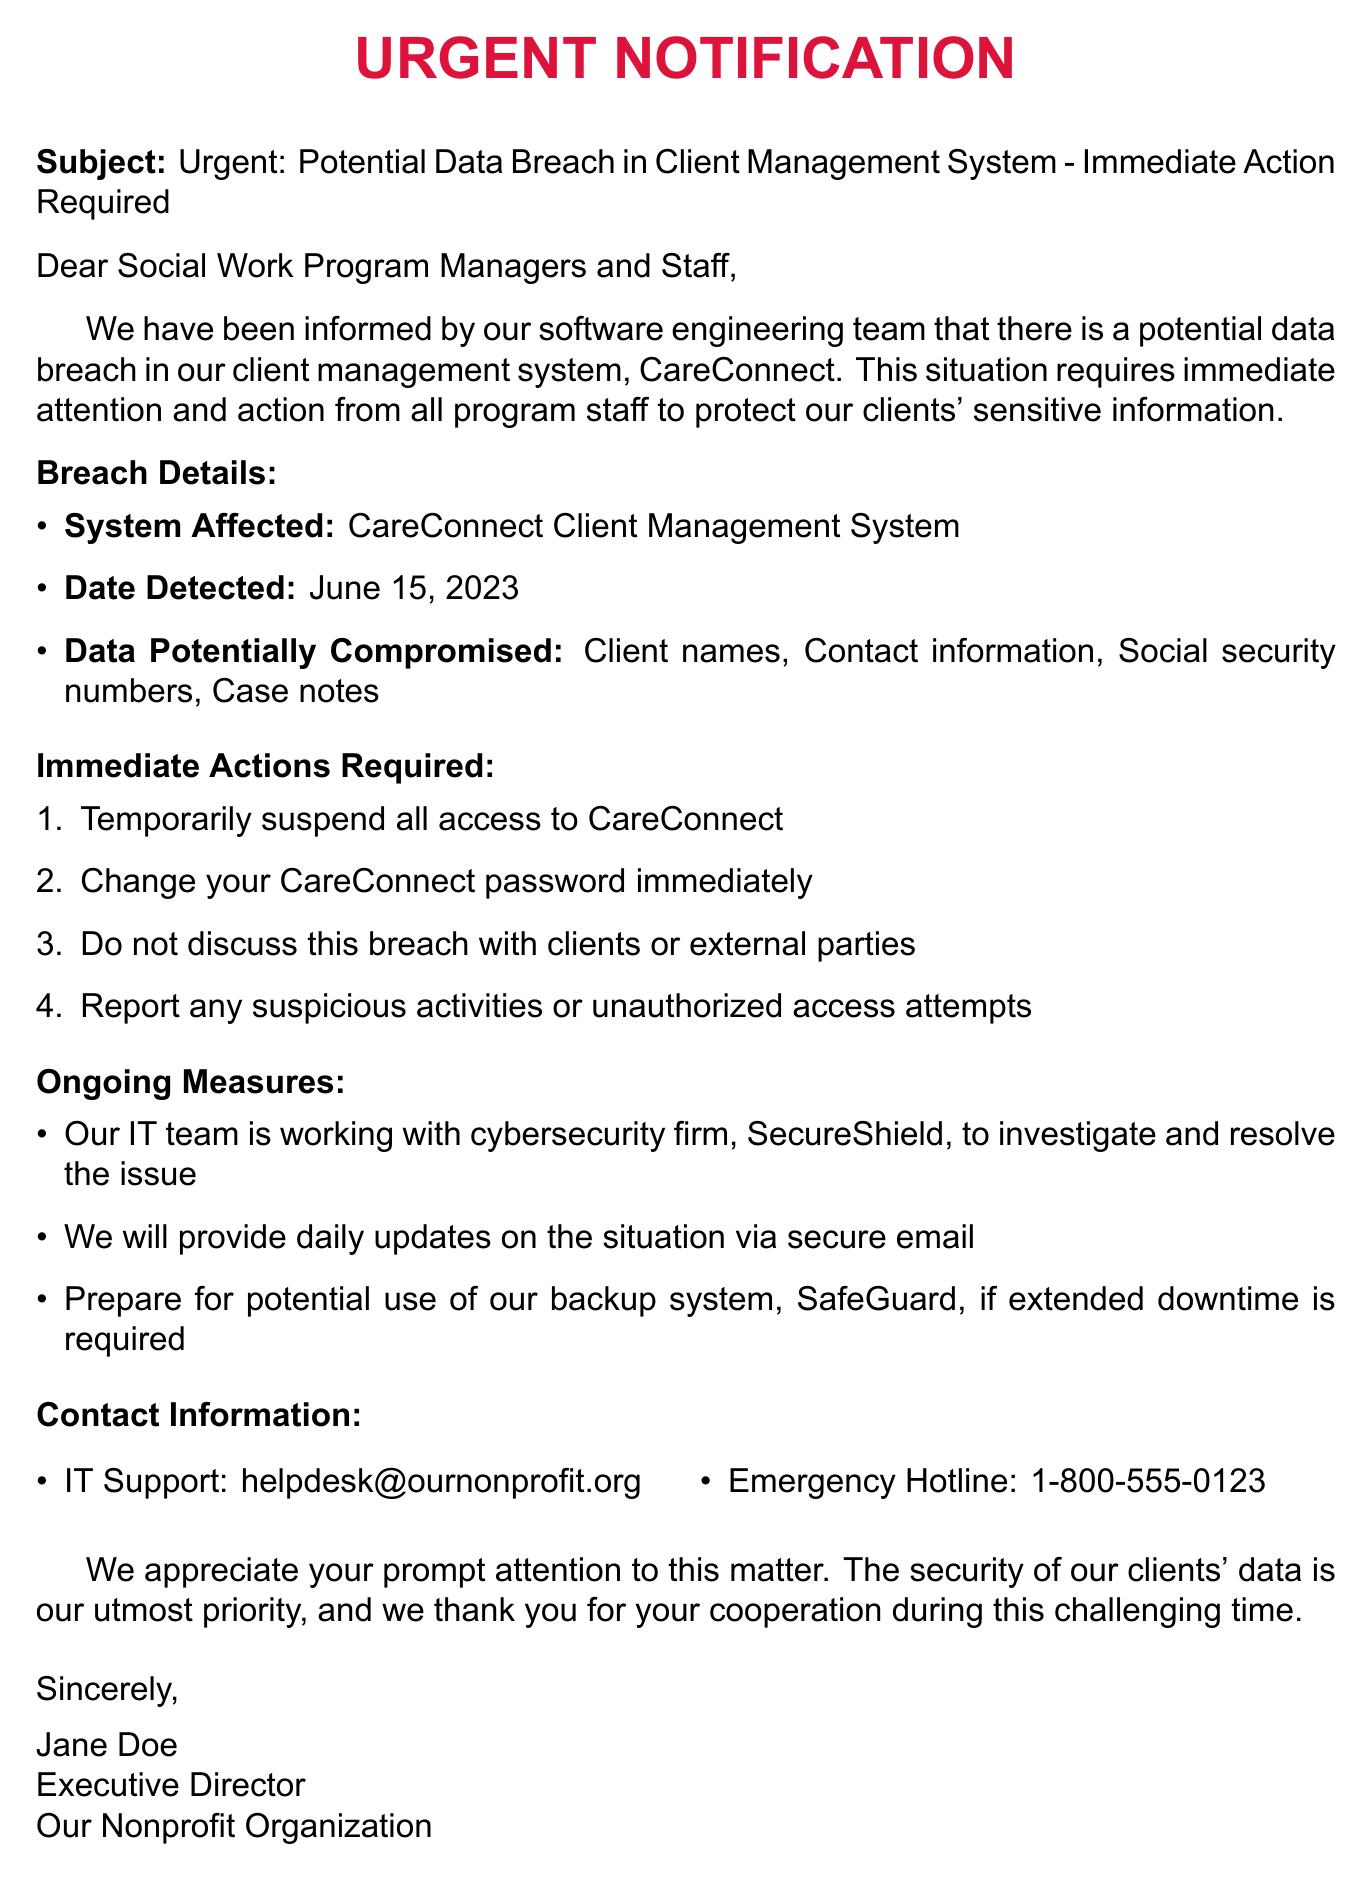What is the subject of the email? The subject provides a clear indication of the email's purpose, stating there is a potential data breach that requires immediate action.
Answer: Urgent: Potential Data Breach in Client Management System - Immediate Action Required What system is affected by the data breach? The document specifies the name of the client management system that may have been compromised.
Answer: CareConnect Client Management System When was the potential breach detected? The date detected indicates when the issue was first identified, which is crucial for assessing the timeline of the incident.
Answer: June 15, 2023 What data is potentially compromised? The document lists specific types of sensitive information that may have been exposed due to the breach.
Answer: Client names, Contact information, Social security numbers, Case notes What is the first immediate action required? Understanding the first step in the action plan helps staff respond appropriately to the situation.
Answer: Temporarily suspend all access to CareConnect Who is working with the IT team to resolve the issue? This identifies the cybersecurity firm involved in helping the organization address the breach effectively.
Answer: SecureShield What should staff do if they notice suspicious activities? It’s important for staff to know how to respond if they observe something unusual related to the system.
Answer: Report any suspicious activities or unauthorized access attempts How will updates about the breach be communicated? Knowing how information will be shared helps maintain communication during this urgent situation.
Answer: Daily updates on the situation via secure email Who is the sender of the email? Identifying the sender gives context to the email, indicating the level of urgency and importance.
Answer: Jane Doe 